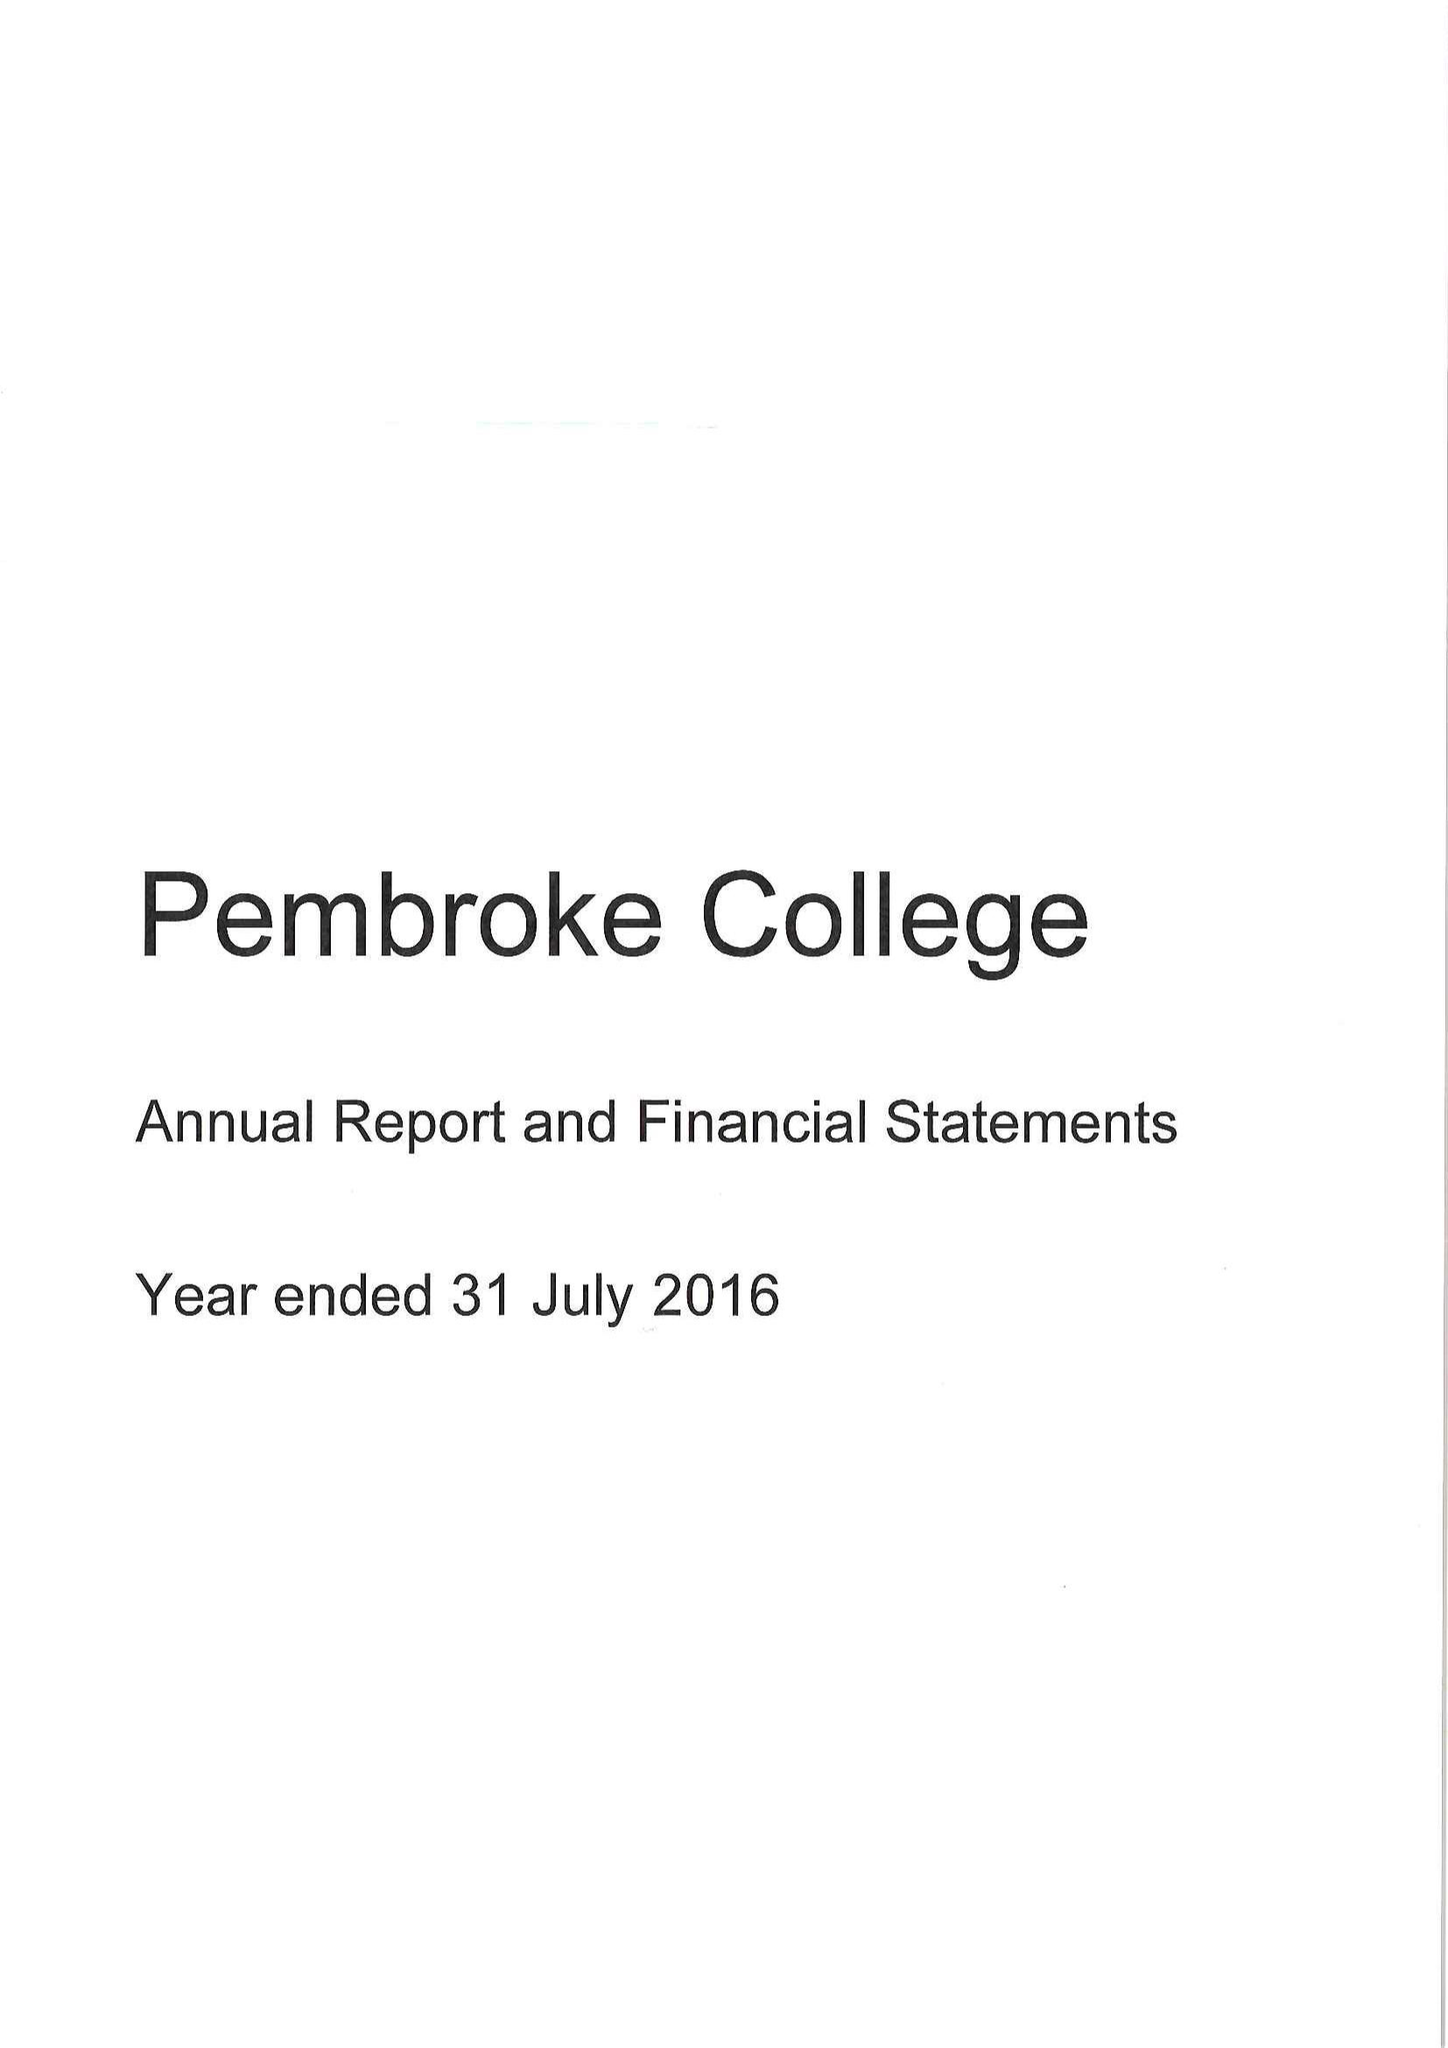What is the value for the charity_number?
Answer the question using a single word or phrase. 1137498 